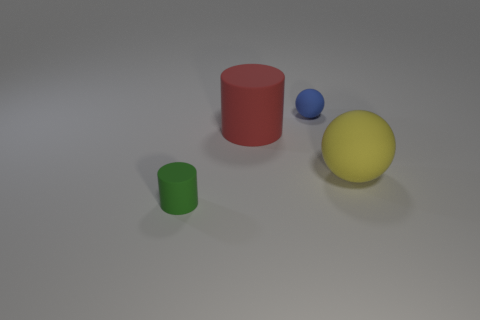Is the size of the yellow rubber thing behind the green rubber cylinder the same as the large red rubber thing?
Offer a very short reply. Yes. Is there any other thing of the same color as the tiny matte cylinder?
Your answer should be very brief. No. The blue thing is what shape?
Provide a succinct answer. Sphere. What number of tiny objects are in front of the red rubber object and right of the large cylinder?
Offer a terse response. 0. Do the small cylinder and the tiny ball have the same color?
Provide a short and direct response. No. There is a tiny blue thing that is the same shape as the yellow thing; what is it made of?
Offer a terse response. Rubber. Is there anything else that is the same material as the red thing?
Offer a very short reply. Yes. Is the number of red cylinders behind the big red object the same as the number of small green matte cylinders that are right of the tiny blue sphere?
Make the answer very short. Yes. Does the yellow sphere have the same material as the blue object?
Provide a short and direct response. Yes. What number of yellow things are either big balls or rubber objects?
Ensure brevity in your answer.  1. 